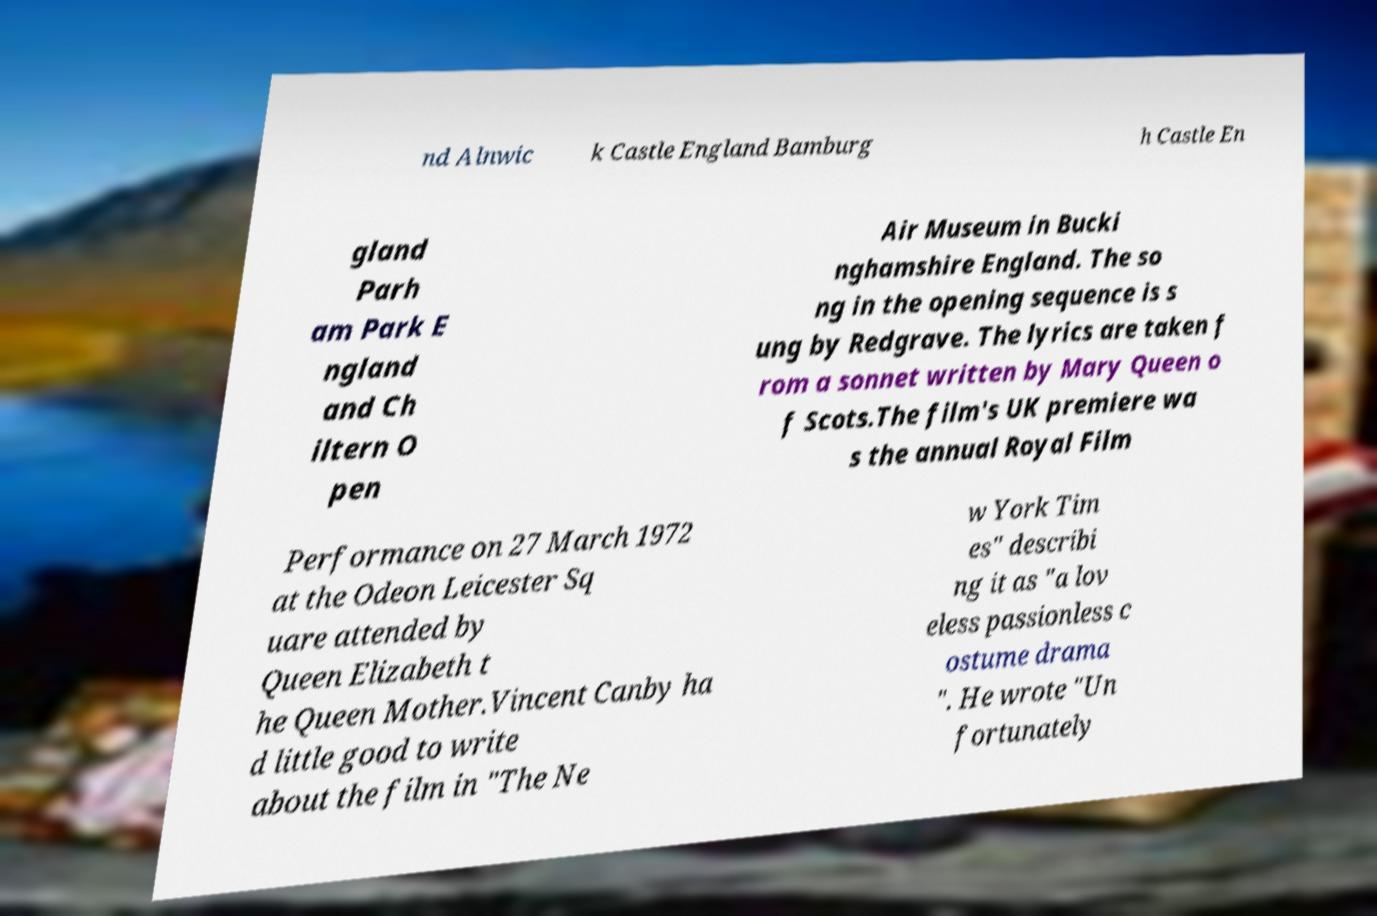There's text embedded in this image that I need extracted. Can you transcribe it verbatim? nd Alnwic k Castle England Bamburg h Castle En gland Parh am Park E ngland and Ch iltern O pen Air Museum in Bucki nghamshire England. The so ng in the opening sequence is s ung by Redgrave. The lyrics are taken f rom a sonnet written by Mary Queen o f Scots.The film's UK premiere wa s the annual Royal Film Performance on 27 March 1972 at the Odeon Leicester Sq uare attended by Queen Elizabeth t he Queen Mother.Vincent Canby ha d little good to write about the film in "The Ne w York Tim es" describi ng it as "a lov eless passionless c ostume drama ". He wrote "Un fortunately 